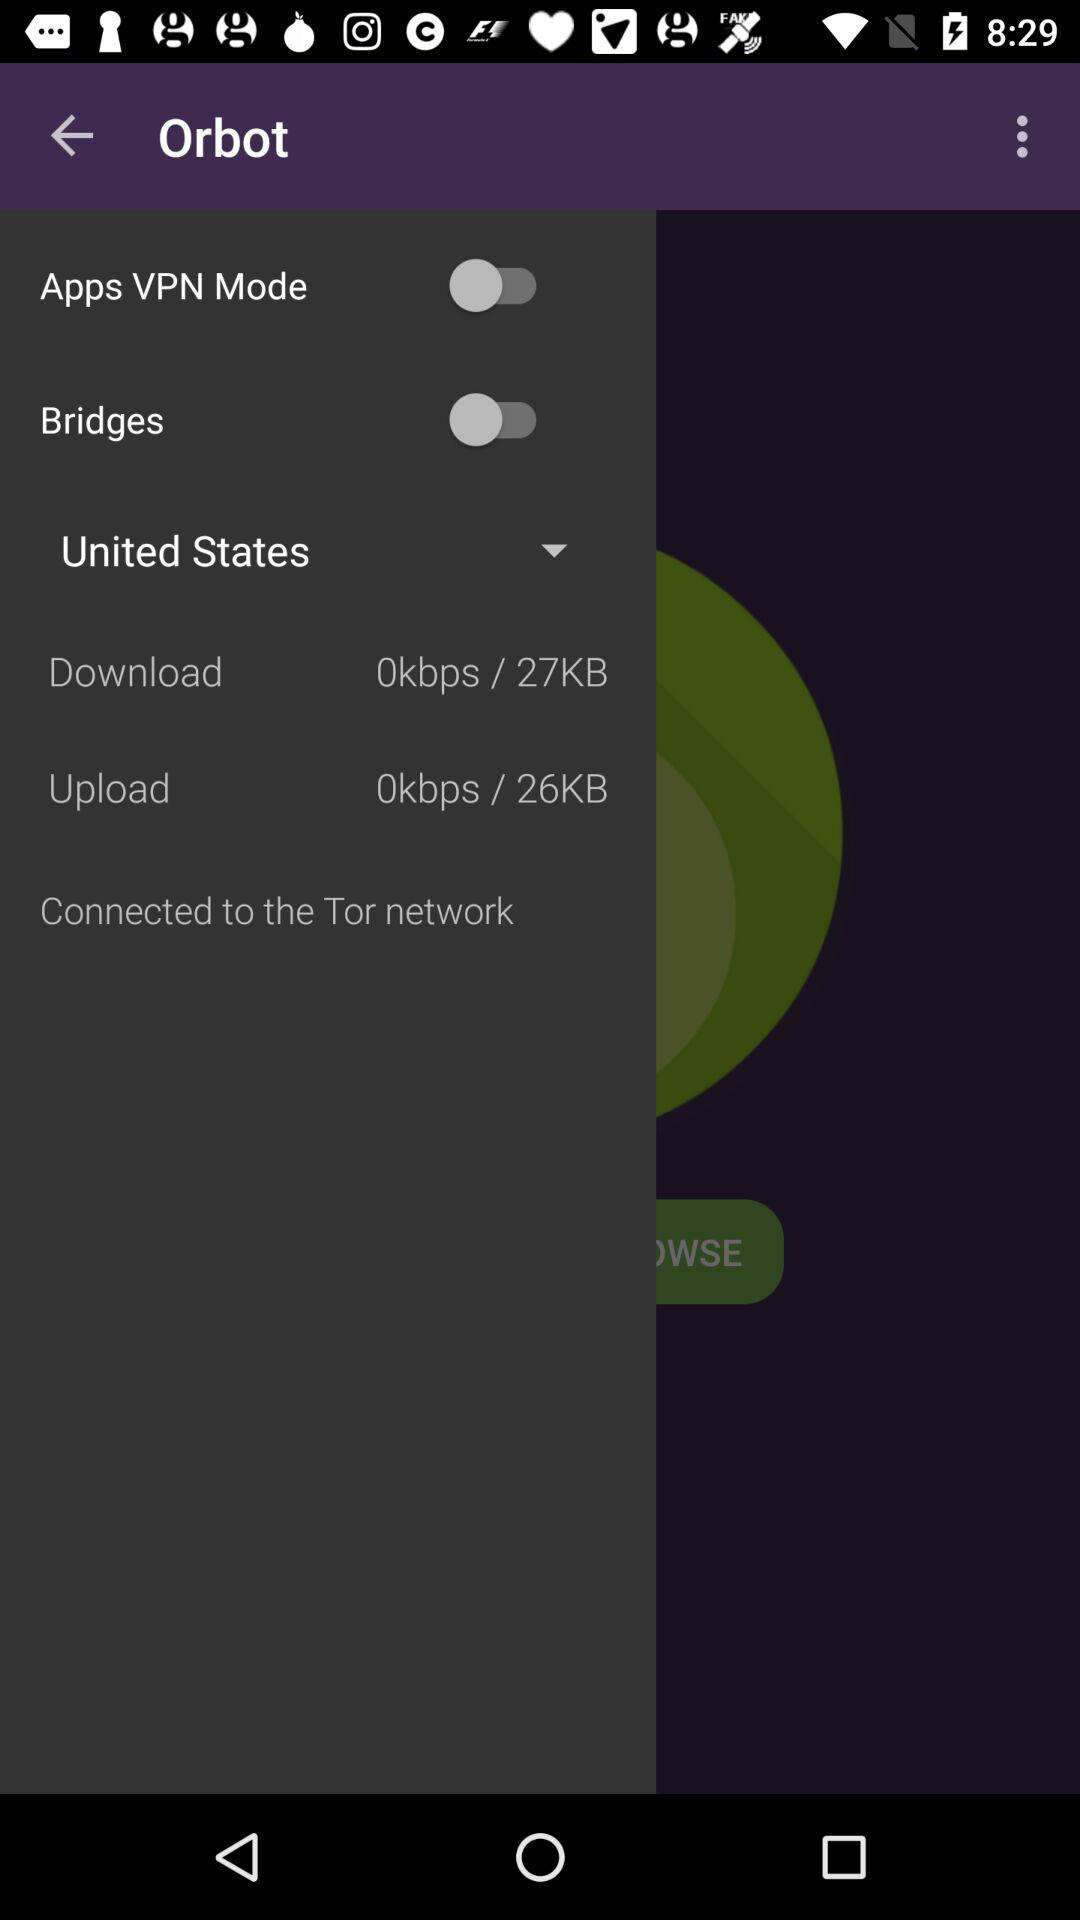What is the upload speed? The upload speed is 0 kbps / 26KB. 